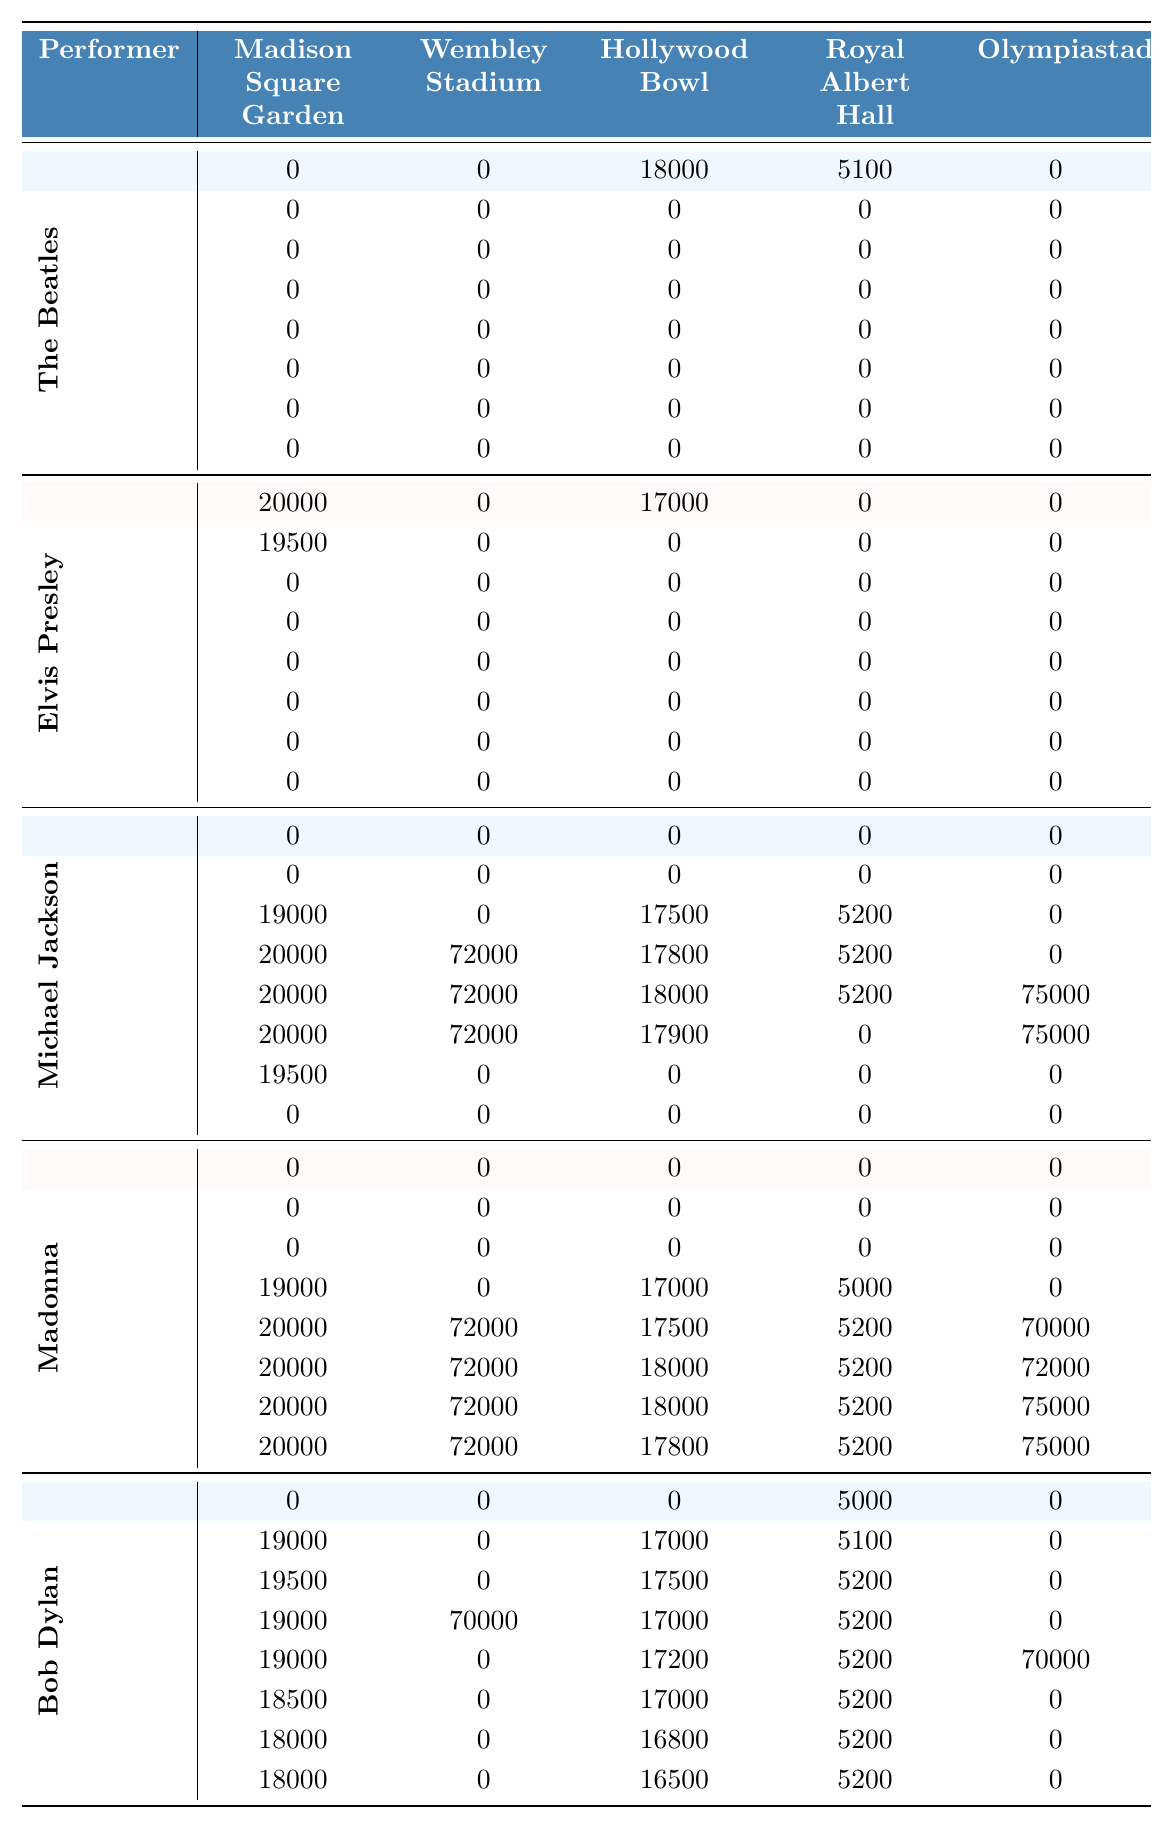What year did The Beatles perform at the Hollywood Bowl? The table shows that The Beatles had attendance numbers for one year at the Hollywood Bowl, which is 1965 with 18,000 attendees.
Answer: 1965 What is the highest attendance recorded for Michael Jackson, and in which venue? By examining the table, Michael Jackson's highest attendance is 72,000, recorded at Wembley Stadium in the years 1980, 1985, and 1990.
Answer: 72,000 at Wembley Stadium What is the average attendance for Elvis Presley at Madison Square Garden over the years he performed there? Elvis Presley performed at Madison Square Garden in the years 1965, 1966, and 1990, with attendance of 20,000, 19,500, and 0 respectively. To find the average: (20000 + 19500 + 0) / 3 = 13166.67.
Answer: 13,167 Did Madonna ever have an attendance of 0 in any venue? By checking the table, it is clear that Madonna had 0 attendance in all venues for several years, particularly 1965, 1966, and 1967.
Answer: Yes Which performer had consistent attendance across most years at Madison Square Garden? By reviewing the data for Madison Square Garden, Bob Dylan had attendance ranging from 18,000 to 19,500 consistently over six years (1966-1990).
Answer: Bob Dylan What is the total attendance for Bob Dylan at Hollywood Bowl from 1970 to 1990? Looking at the data for Bob Dylan from Hollywood Bowl during the years 1970 to 1990: 17,000 (1970) + 17,500 (1975) + 17,000 (1980) + 17,200 (1985) + 17,000 (1990) = 85,700.
Answer: 85,700 In which year did Michael Jackson perform at the Royal Albert Hall, and what was the attendance? The table indicates that Michael Jackson performed at the Royal Albert Hall in 1975, with an attendance of 5,200.
Answer: 1975, 5,200 What is the difference in attendance for Madonna between 1985 and 1990 at Olympiastadion? Madonna's attendance at Olympiastadion in 1985 was 70,000 and in 1990 it was 75,000. The difference is 75,000 - 70,000 = 5,000.
Answer: 5,000 Was there any year when both The Beatles and Elvis Presley performed at the same venue? The data shows that there are no recorded attendance numbers for both The Beatles and Elvis Presley during the same year at any venue simultaneously.
Answer: No Which performer had the highest average attendance across all venues in the year 1985? Checking the table for 1985 shows Madonna with a total of 70,000 at Olympiastadion, whereas others have lower numbers. Therefore, she had the highest attendance in that year across all venues.
Answer: Madonna 